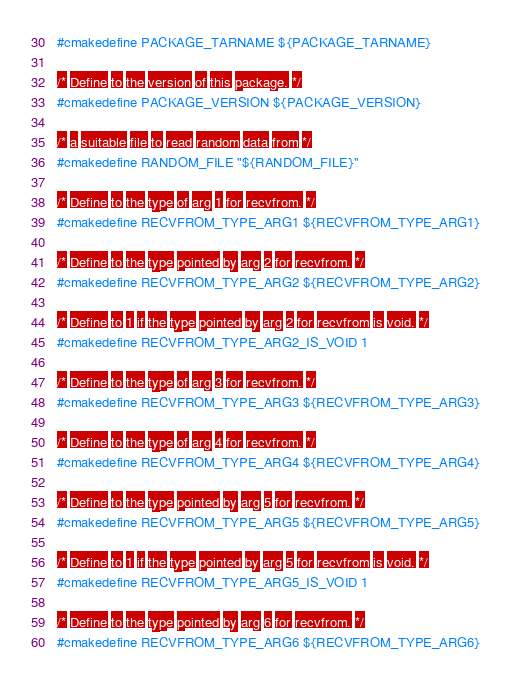Convert code to text. <code><loc_0><loc_0><loc_500><loc_500><_CMake_>#cmakedefine PACKAGE_TARNAME ${PACKAGE_TARNAME}

/* Define to the version of this package. */
#cmakedefine PACKAGE_VERSION ${PACKAGE_VERSION}

/* a suitable file to read random data from */
#cmakedefine RANDOM_FILE "${RANDOM_FILE}"

/* Define to the type of arg 1 for recvfrom. */
#cmakedefine RECVFROM_TYPE_ARG1 ${RECVFROM_TYPE_ARG1}

/* Define to the type pointed by arg 2 for recvfrom. */
#cmakedefine RECVFROM_TYPE_ARG2 ${RECVFROM_TYPE_ARG2}

/* Define to 1 if the type pointed by arg 2 for recvfrom is void. */
#cmakedefine RECVFROM_TYPE_ARG2_IS_VOID 1

/* Define to the type of arg 3 for recvfrom. */
#cmakedefine RECVFROM_TYPE_ARG3 ${RECVFROM_TYPE_ARG3}

/* Define to the type of arg 4 for recvfrom. */
#cmakedefine RECVFROM_TYPE_ARG4 ${RECVFROM_TYPE_ARG4}

/* Define to the type pointed by arg 5 for recvfrom. */
#cmakedefine RECVFROM_TYPE_ARG5 ${RECVFROM_TYPE_ARG5}

/* Define to 1 if the type pointed by arg 5 for recvfrom is void. */
#cmakedefine RECVFROM_TYPE_ARG5_IS_VOID 1

/* Define to the type pointed by arg 6 for recvfrom. */
#cmakedefine RECVFROM_TYPE_ARG6 ${RECVFROM_TYPE_ARG6}
</code> 